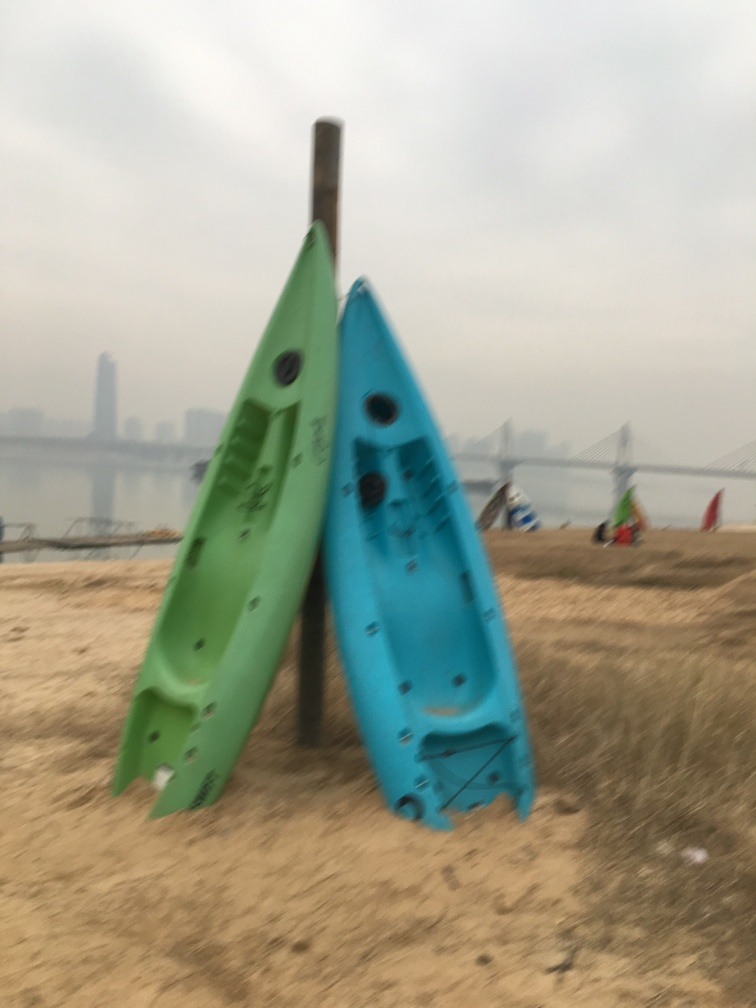What might these boats imply about the location where the photo was taken? The presence of these small boats, often used for leisurely activities like kayaking, suggests that the location could be a recreational area near a body of water. The sandy shore and the poles used to store the boats upright indicate that this is a place set up for easy access to the water for enjoyment. 